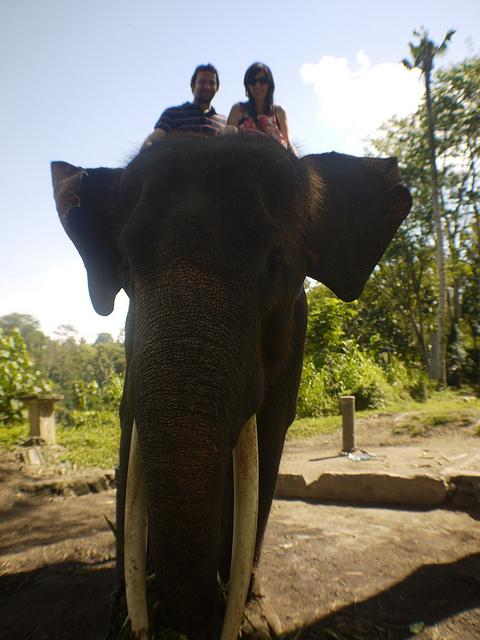Where can you find this animal?

Choices:
A) new jersey
B) india
C) siberia
D) russia india 